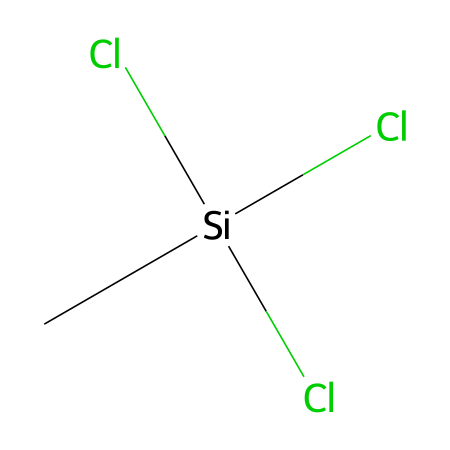What is the molecular formula of this compound? The molecular formula can be determined by counting the atoms present in the chemical structure. In this case, there is one carbon atom (C), one silicon atom (Si), and three chlorine atoms (Cl), resulting in the formula CSiCl3.
Answer: CSiCl3 How many chlorine atoms are present in methyltrichlorosilane? By examining the chemical structure, we can see that there are three chlorine atoms attached to the silicon atom.
Answer: three What type of bonds are present in this molecule? The molecule exhibits covalent bonds as it consists of non-metals (carbon and chlorine) bonding with silicon, a metalloid. In this case, the carbon is bonded to silicon and the silicon is bonded to three chlorines via covalent bonds.
Answer: covalent What is the functional group present in methyltrichlorosilane? The presence of chlorine atoms in this silane compound indicates that it contains a chlorosilane functional group. The structure shows that silicon is bonded to chlorines and one methyl group.
Answer: chlorosilane Is methyltrichlorosilane a saturated or unsaturated compound? Since there are no double or triple bonds between the carbon and silicon or between the silicon and chlorine atoms, methyltrichlorosilane is classified as a saturated compound.
Answer: saturated What does the "methyl" refer to in methyltrichlorosilane? The term "methyl" refers to the one carbon atom (CH₃) that is part of the molecule. It signifies that the compound includes a methyl group which is directly bonded to silicon.
Answer: one carbon atom 